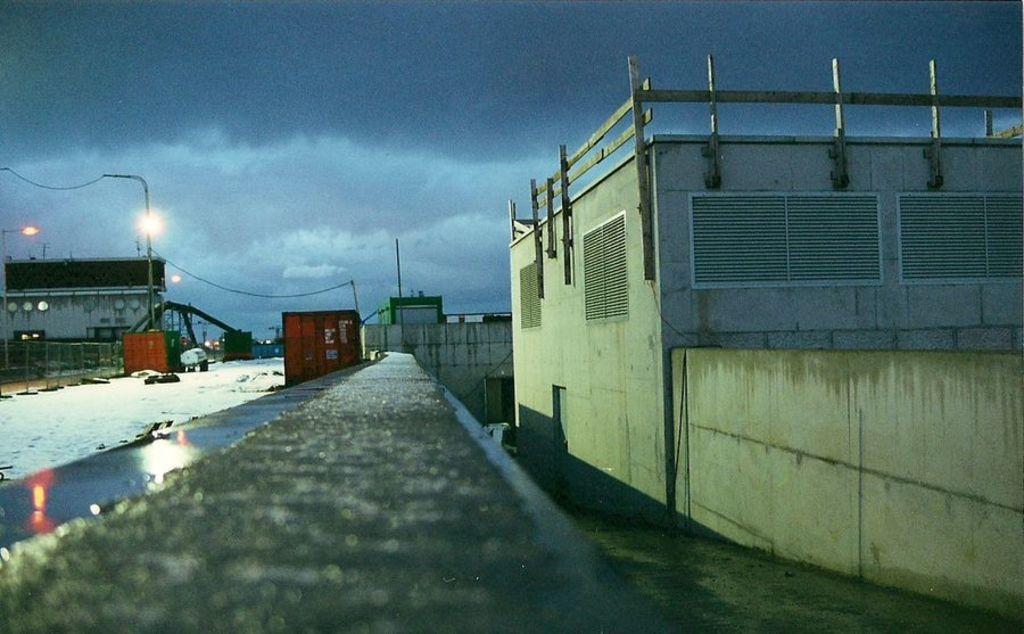Could you give a brief overview of what you see in this image? In the image we can see there are buildings and the ground is covered with snow. There are street light poles on the footpath. 